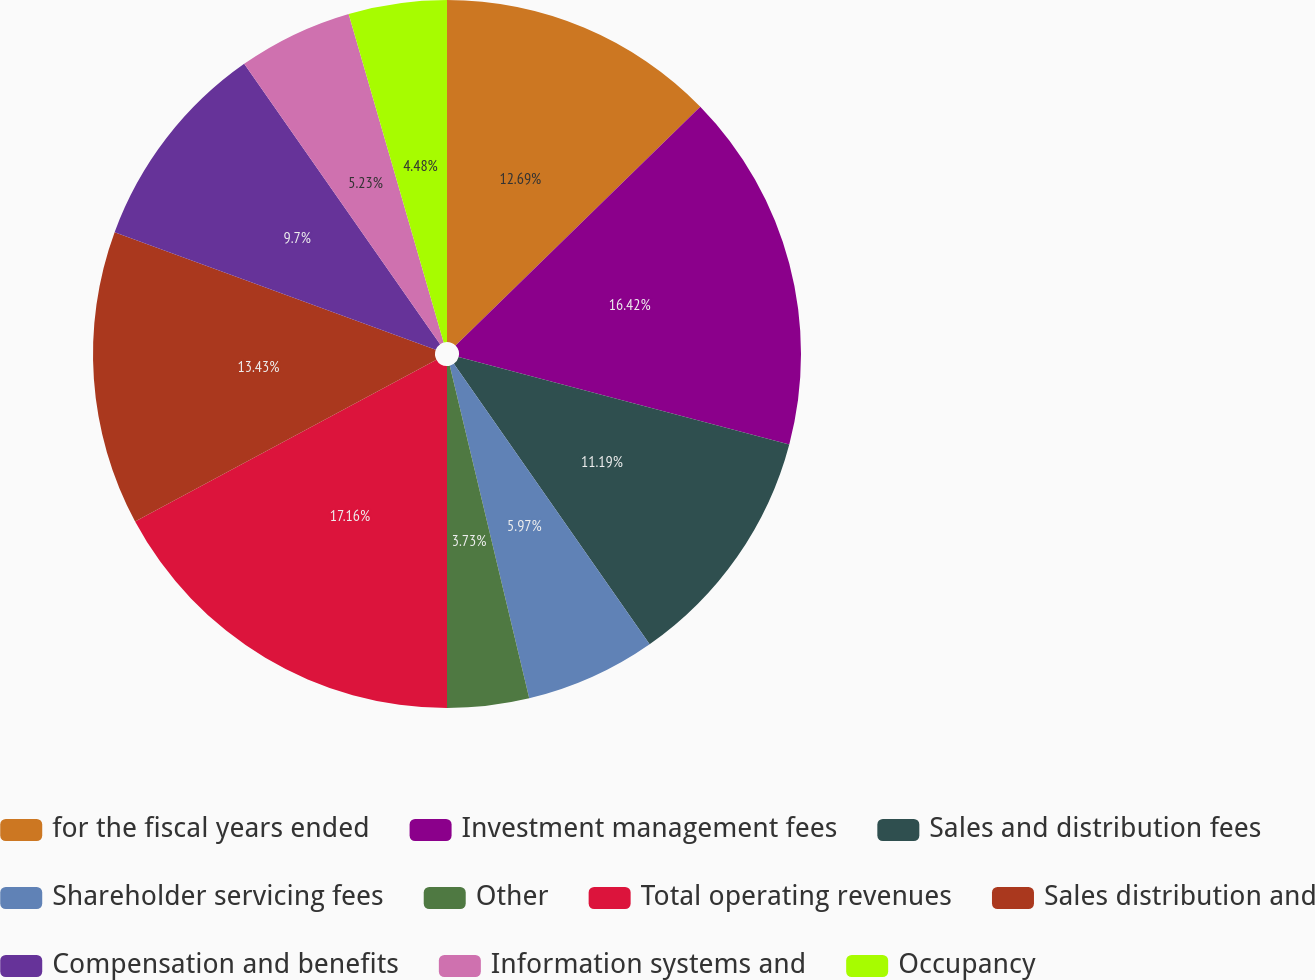Convert chart. <chart><loc_0><loc_0><loc_500><loc_500><pie_chart><fcel>for the fiscal years ended<fcel>Investment management fees<fcel>Sales and distribution fees<fcel>Shareholder servicing fees<fcel>Other<fcel>Total operating revenues<fcel>Sales distribution and<fcel>Compensation and benefits<fcel>Information systems and<fcel>Occupancy<nl><fcel>12.69%<fcel>16.42%<fcel>11.19%<fcel>5.97%<fcel>3.73%<fcel>17.16%<fcel>13.43%<fcel>9.7%<fcel>5.23%<fcel>4.48%<nl></chart> 